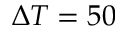Convert formula to latex. <formula><loc_0><loc_0><loc_500><loc_500>\Delta T = 5 0</formula> 